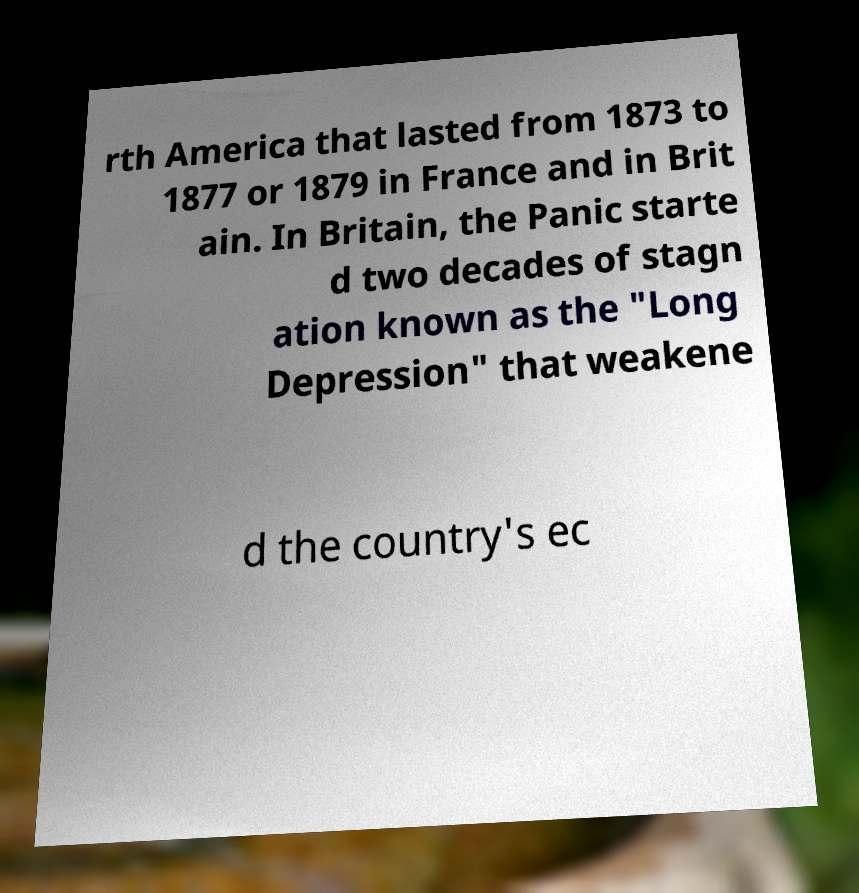Can you read and provide the text displayed in the image?This photo seems to have some interesting text. Can you extract and type it out for me? rth America that lasted from 1873 to 1877 or 1879 in France and in Brit ain. In Britain, the Panic starte d two decades of stagn ation known as the "Long Depression" that weakene d the country's ec 